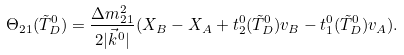<formula> <loc_0><loc_0><loc_500><loc_500>\Theta _ { 2 1 } ( \tilde { T } ^ { 0 } _ { D } ) = \frac { \Delta m ^ { 2 } _ { 2 1 } } { 2 | \vec { k } ^ { 0 } | } ( X _ { B } - X _ { A } + t ^ { 0 } _ { 2 } ( \tilde { T } ^ { 0 } _ { D } ) v _ { B } - t ^ { 0 } _ { 1 } ( \tilde { T } ^ { 0 } _ { D } ) v _ { A } ) .</formula> 